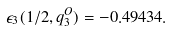<formula> <loc_0><loc_0><loc_500><loc_500>\epsilon _ { 3 } ( 1 / 2 , q _ { 3 } ^ { O } ) = - 0 . 4 9 4 3 4 .</formula> 